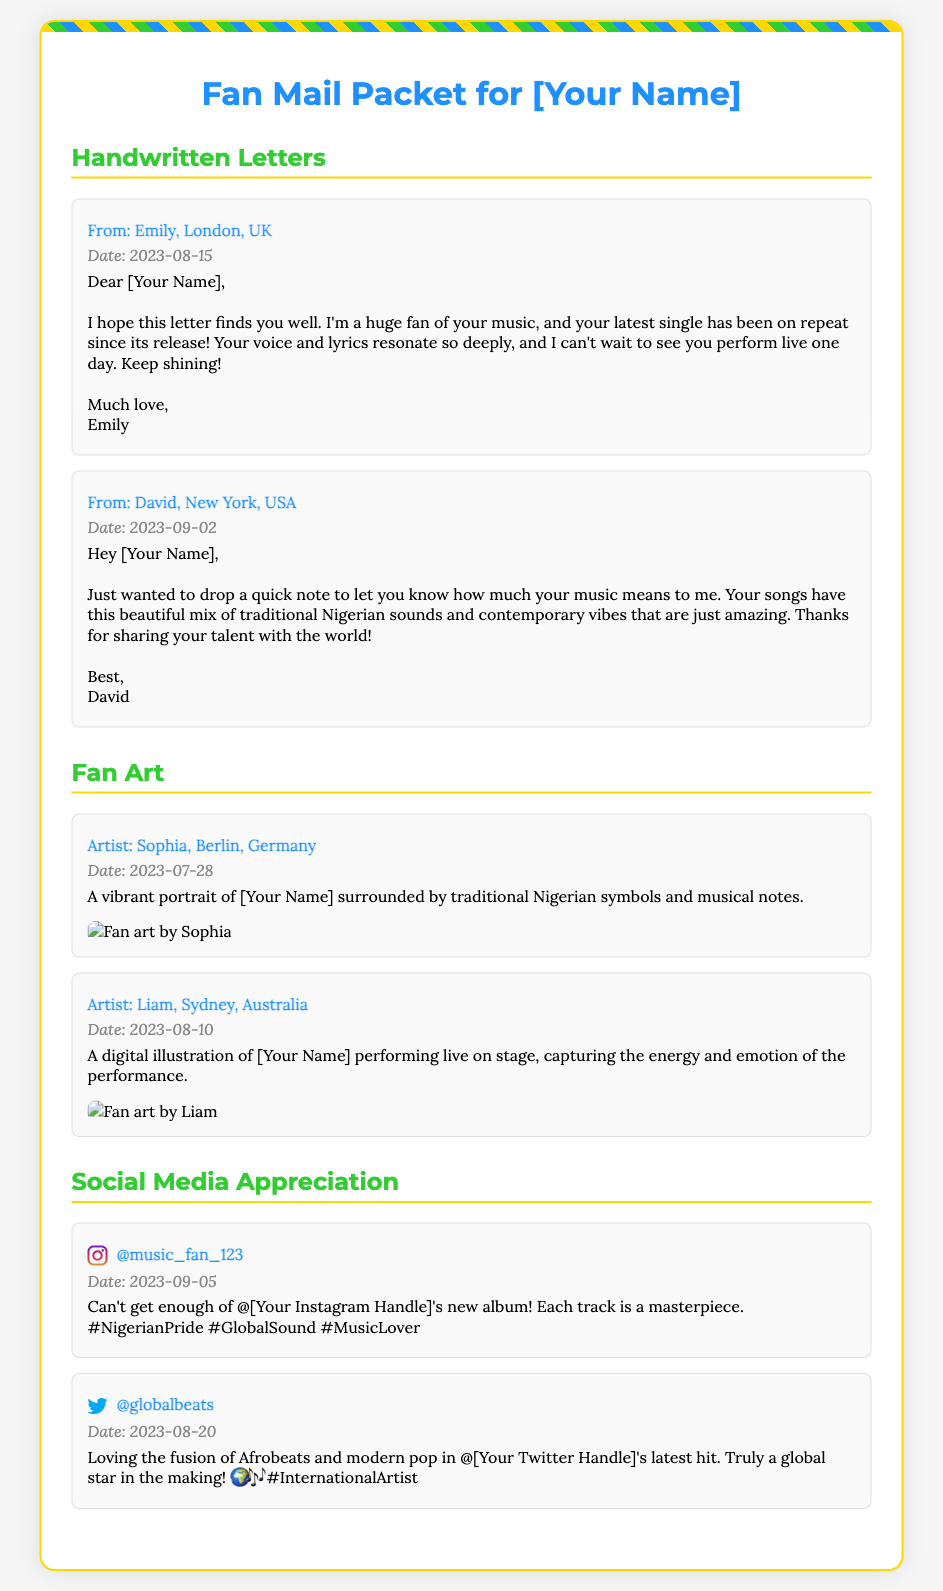What is the title of the document? The title of the document is prominently displayed at the top and indicates the packet's purpose.
Answer: Fan Mail Packet for [Your Name] Who wrote a letter from London? The letter from London is attributed to a fan who expresses admiration.
Answer: Emily What date did David send his letter? The document includes specific dates when each letter is written.
Answer: 2023-09-02 Which artist created a portrait of [Your Name]? The document lists fans and their respective artworks, including the artist's location.
Answer: Sophia, Berlin, Germany How many handwritten letters are included? The document details the number of letters in the handwritten section.
Answer: 2 What platform is @music_fan_123 using to show appreciation? The document specifies the social media platform linked to the appreciation post.
Answer: Instagram What type of art is featured from Liam? The document describes the kind of fan art provided by Liam.
Answer: Digital illustration What is the date of the fan art from Sophia? The document shows the specific date associated with the fan art received.
Answer: 2023-07-28 What theme is captured in Sophia's fan art? The description elaborates on the theme and elements present in Sophia's artwork.
Answer: Traditional Nigerian symbols and musical notes 